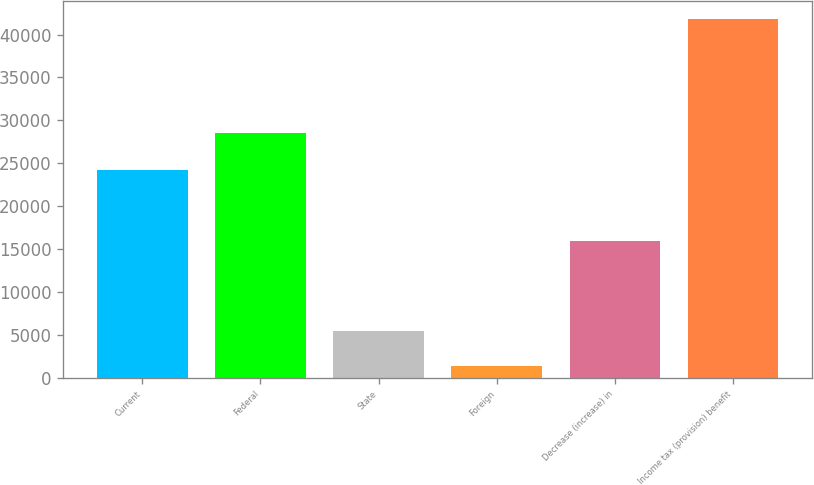Convert chart. <chart><loc_0><loc_0><loc_500><loc_500><bar_chart><fcel>Current<fcel>Federal<fcel>State<fcel>Foreign<fcel>Decrease (increase) in<fcel>Income tax (provision) benefit<nl><fcel>24233<fcel>28488<fcel>5426.9<fcel>1389<fcel>15989<fcel>41768<nl></chart> 